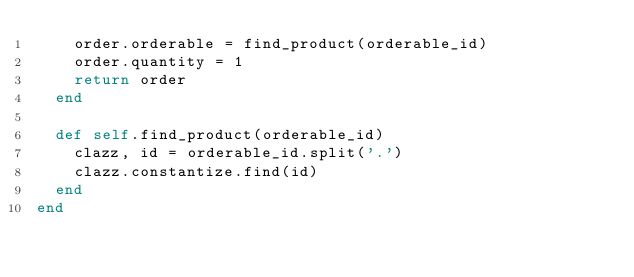<code> <loc_0><loc_0><loc_500><loc_500><_Ruby_>    order.orderable = find_product(orderable_id) 
    order.quantity = 1
    return order
  end

  def self.find_product(orderable_id)
    clazz, id = orderable_id.split('.')
    clazz.constantize.find(id)
  end
end
</code> 